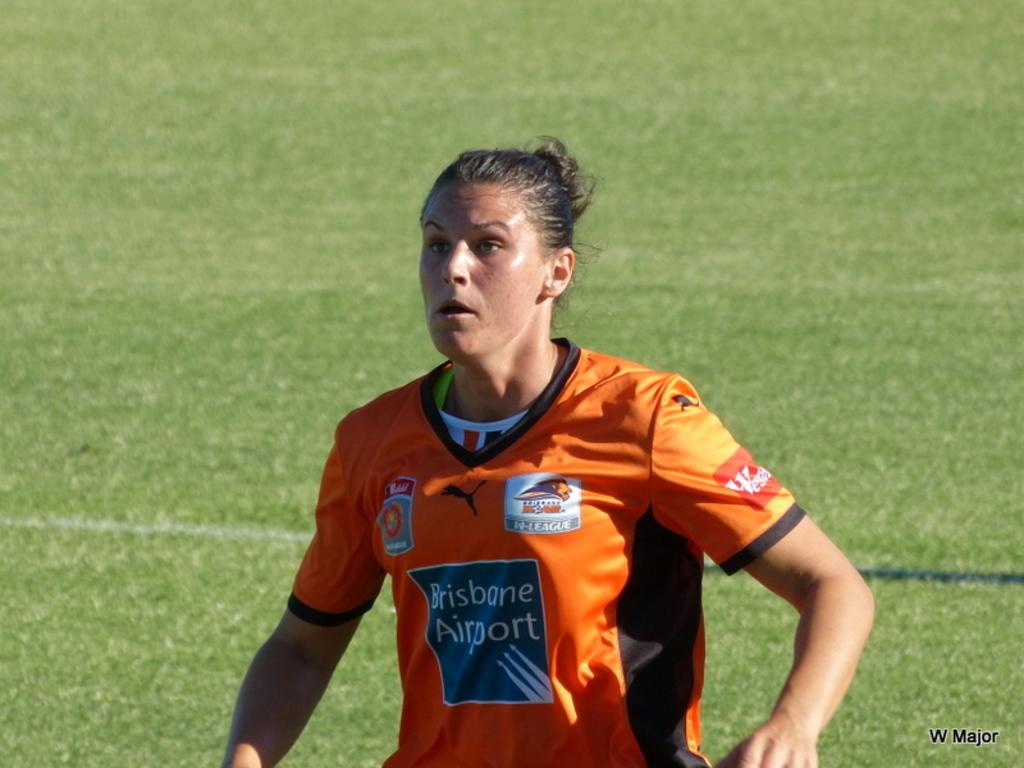What colour is the player's top?
Offer a terse response. Orange. 